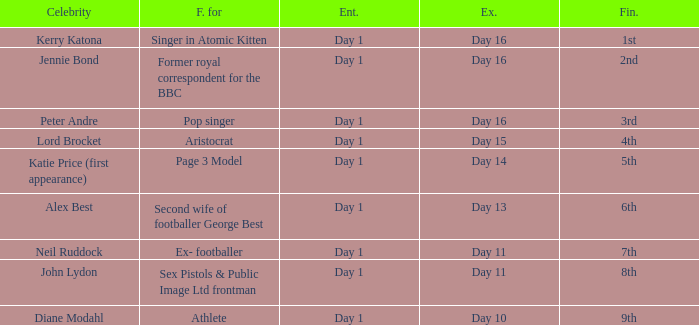Name the entered for famous for page 3 model Day 1. 